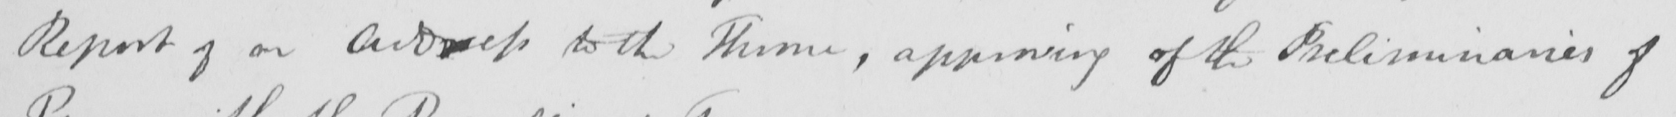Please provide the text content of this handwritten line. Report of an address to the Throne , approving of the Preliminaries of 